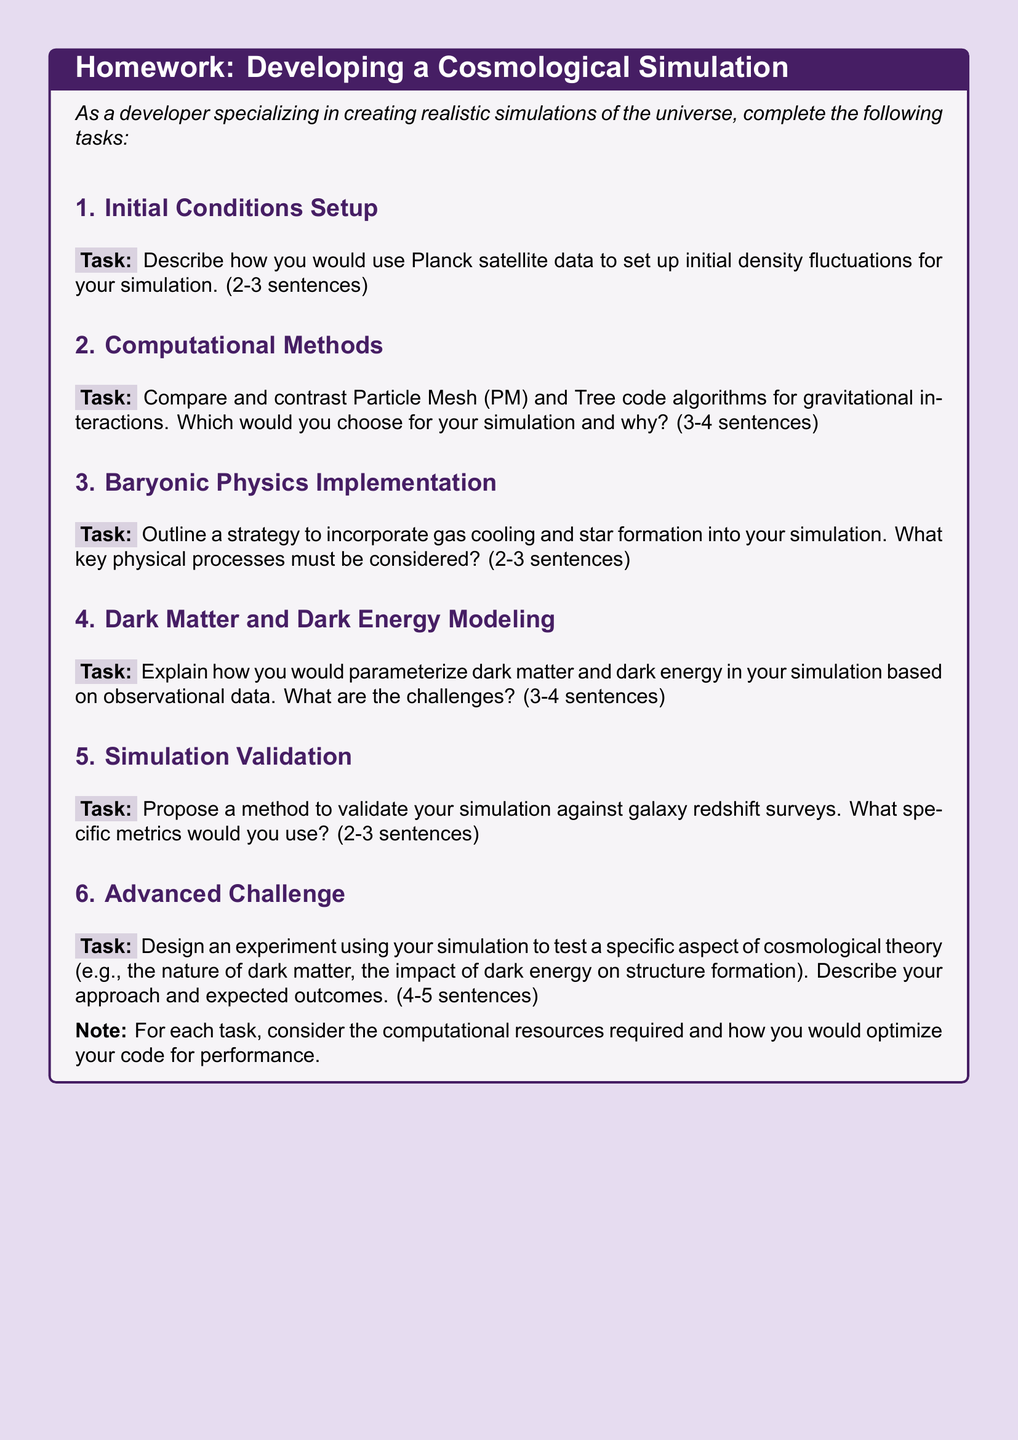what is the main topic of the homework? The main topic of the homework is to develop a cosmological simulation from the Big Bang to the present-day universe.
Answer: cosmological simulation how many tasks are outlined in the homework? The homework outlines six tasks related to developing a cosmological simulation.
Answer: six which algorithm is mentioned for gravitational interactions? The homework mentions Particle Mesh (PM) and Tree code algorithms for gravitational interactions.
Answer: Particle Mesh and Tree code what is one of the challenges discussed in the homework? The homework highlights challenges in parameterizing dark matter and dark energy based on observational data.
Answer: challenges in parameterizing dark matter and dark energy what is the expected outcome for the advanced challenge task? The advanced challenge task expects a description of an experiment design to test a specific aspect of cosmological theory and its outcomes.
Answer: expected outcomes how are initial conditions for the simulation supposed to be set up? Initial conditions for the simulation are to be set up using Planck satellite data to describe initial density fluctuations.
Answer: Planck satellite data 